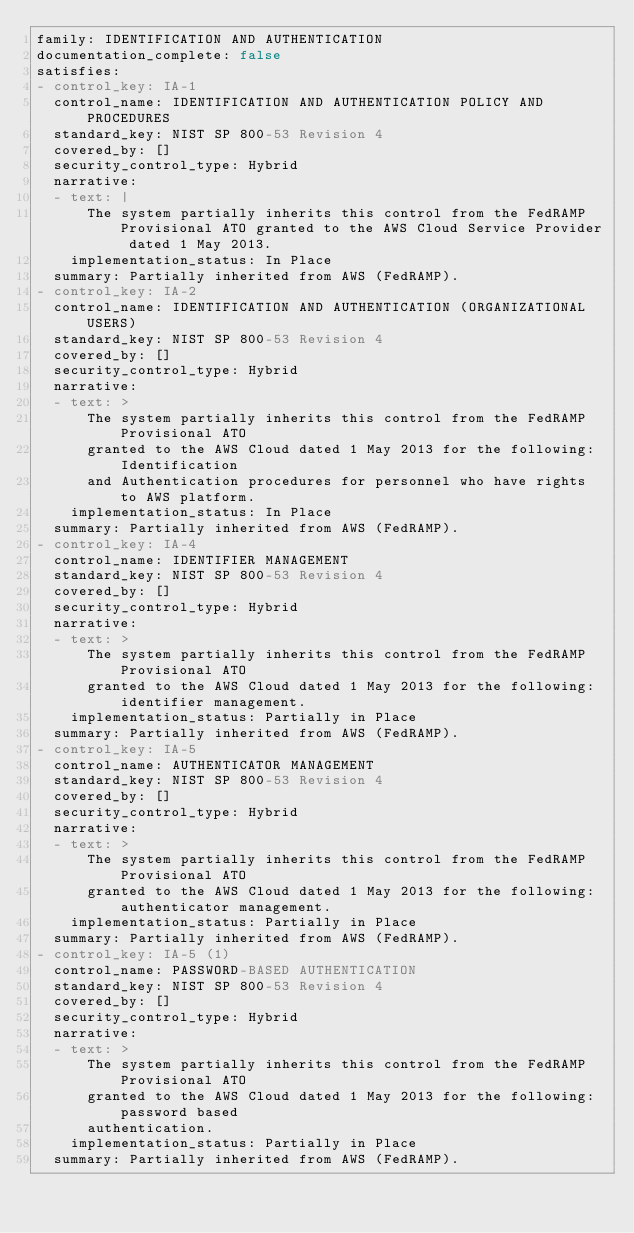<code> <loc_0><loc_0><loc_500><loc_500><_YAML_>family: IDENTIFICATION AND AUTHENTICATION
documentation_complete: false
satisfies:
- control_key: IA-1
  control_name: IDENTIFICATION AND AUTHENTICATION POLICY AND PROCEDURES
  standard_key: NIST SP 800-53 Revision 4
  covered_by: []
  security_control_type: Hybrid
  narrative:
  - text: |
      The system partially inherits this control from the FedRAMP Provisional ATO granted to the AWS Cloud Service Provider dated 1 May 2013.
    implementation_status: In Place
  summary: Partially inherited from AWS (FedRAMP).
- control_key: IA-2
  control_name: IDENTIFICATION AND AUTHENTICATION (ORGANIZATIONAL USERS)
  standard_key: NIST SP 800-53 Revision 4
  covered_by: []
  security_control_type: Hybrid
  narrative:
  - text: >
      The system partially inherits this control from the FedRAMP Provisional ATO
      granted to the AWS Cloud dated 1 May 2013 for the following: Identification
      and Authentication procedures for personnel who have rights to AWS platform.
    implementation_status: In Place
  summary: Partially inherited from AWS (FedRAMP).
- control_key: IA-4
  control_name: IDENTIFIER MANAGEMENT
  standard_key: NIST SP 800-53 Revision 4
  covered_by: []
  security_control_type: Hybrid
  narrative:
  - text: >
      The system partially inherits this control from the FedRAMP Provisional ATO
      granted to the AWS Cloud dated 1 May 2013 for the following: identifier management.
    implementation_status: Partially in Place
  summary: Partially inherited from AWS (FedRAMP).
- control_key: IA-5
  control_name: AUTHENTICATOR MANAGEMENT
  standard_key: NIST SP 800-53 Revision 4
  covered_by: []
  security_control_type: Hybrid
  narrative:
  - text: >
      The system partially inherits this control from the FedRAMP Provisional ATO
      granted to the AWS Cloud dated 1 May 2013 for the following: authenticator management.
    implementation_status: Partially in Place
  summary: Partially inherited from AWS (FedRAMP).
- control_key: IA-5 (1)
  control_name: PASSWORD-BASED AUTHENTICATION
  standard_key: NIST SP 800-53 Revision 4
  covered_by: []
  security_control_type: Hybrid
  narrative:
  - text: >
      The system partially inherits this control from the FedRAMP Provisional ATO
      granted to the AWS Cloud dated 1 May 2013 for the following: password based
      authentication.
    implementation_status: Partially in Place
  summary: Partially inherited from AWS (FedRAMP).
</code> 